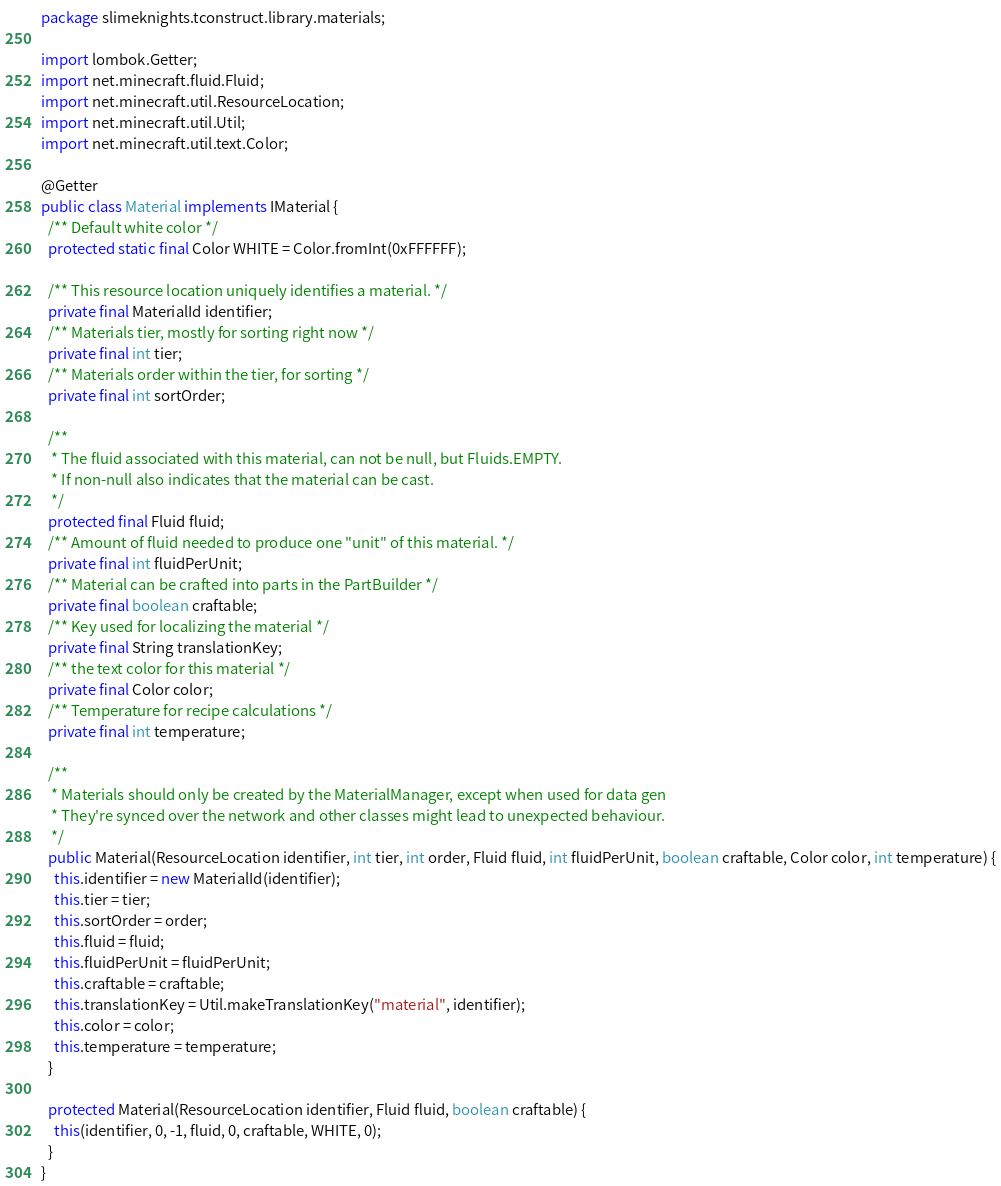<code> <loc_0><loc_0><loc_500><loc_500><_Java_>package slimeknights.tconstruct.library.materials;

import lombok.Getter;
import net.minecraft.fluid.Fluid;
import net.minecraft.util.ResourceLocation;
import net.minecraft.util.Util;
import net.minecraft.util.text.Color;

@Getter
public class Material implements IMaterial {
  /** Default white color */
  protected static final Color WHITE = Color.fromInt(0xFFFFFF);

  /** This resource location uniquely identifies a material. */
  private final MaterialId identifier;
  /** Materials tier, mostly for sorting right now */
  private final int tier;
  /** Materials order within the tier, for sorting */
  private final int sortOrder;

  /**
   * The fluid associated with this material, can not be null, but Fluids.EMPTY.
   * If non-null also indicates that the material can be cast.
   */
  protected final Fluid fluid;
  /** Amount of fluid needed to produce one "unit" of this material. */
  private final int fluidPerUnit;
  /** Material can be crafted into parts in the PartBuilder */
  private final boolean craftable;
  /** Key used for localizing the material */
  private final String translationKey;
  /** the text color for this material */
  private final Color color;
  /** Temperature for recipe calculations */
  private final int temperature;

  /**
   * Materials should only be created by the MaterialManager, except when used for data gen
   * They're synced over the network and other classes might lead to unexpected behaviour.
   */
  public Material(ResourceLocation identifier, int tier, int order, Fluid fluid, int fluidPerUnit, boolean craftable, Color color, int temperature) {
    this.identifier = new MaterialId(identifier);
    this.tier = tier;
    this.sortOrder = order;
    this.fluid = fluid;
    this.fluidPerUnit = fluidPerUnit;
    this.craftable = craftable;
    this.translationKey = Util.makeTranslationKey("material", identifier);
    this.color = color;
    this.temperature = temperature;
  }

  protected Material(ResourceLocation identifier, Fluid fluid, boolean craftable) {
    this(identifier, 0, -1, fluid, 0, craftable, WHITE, 0);
  }
}
</code> 